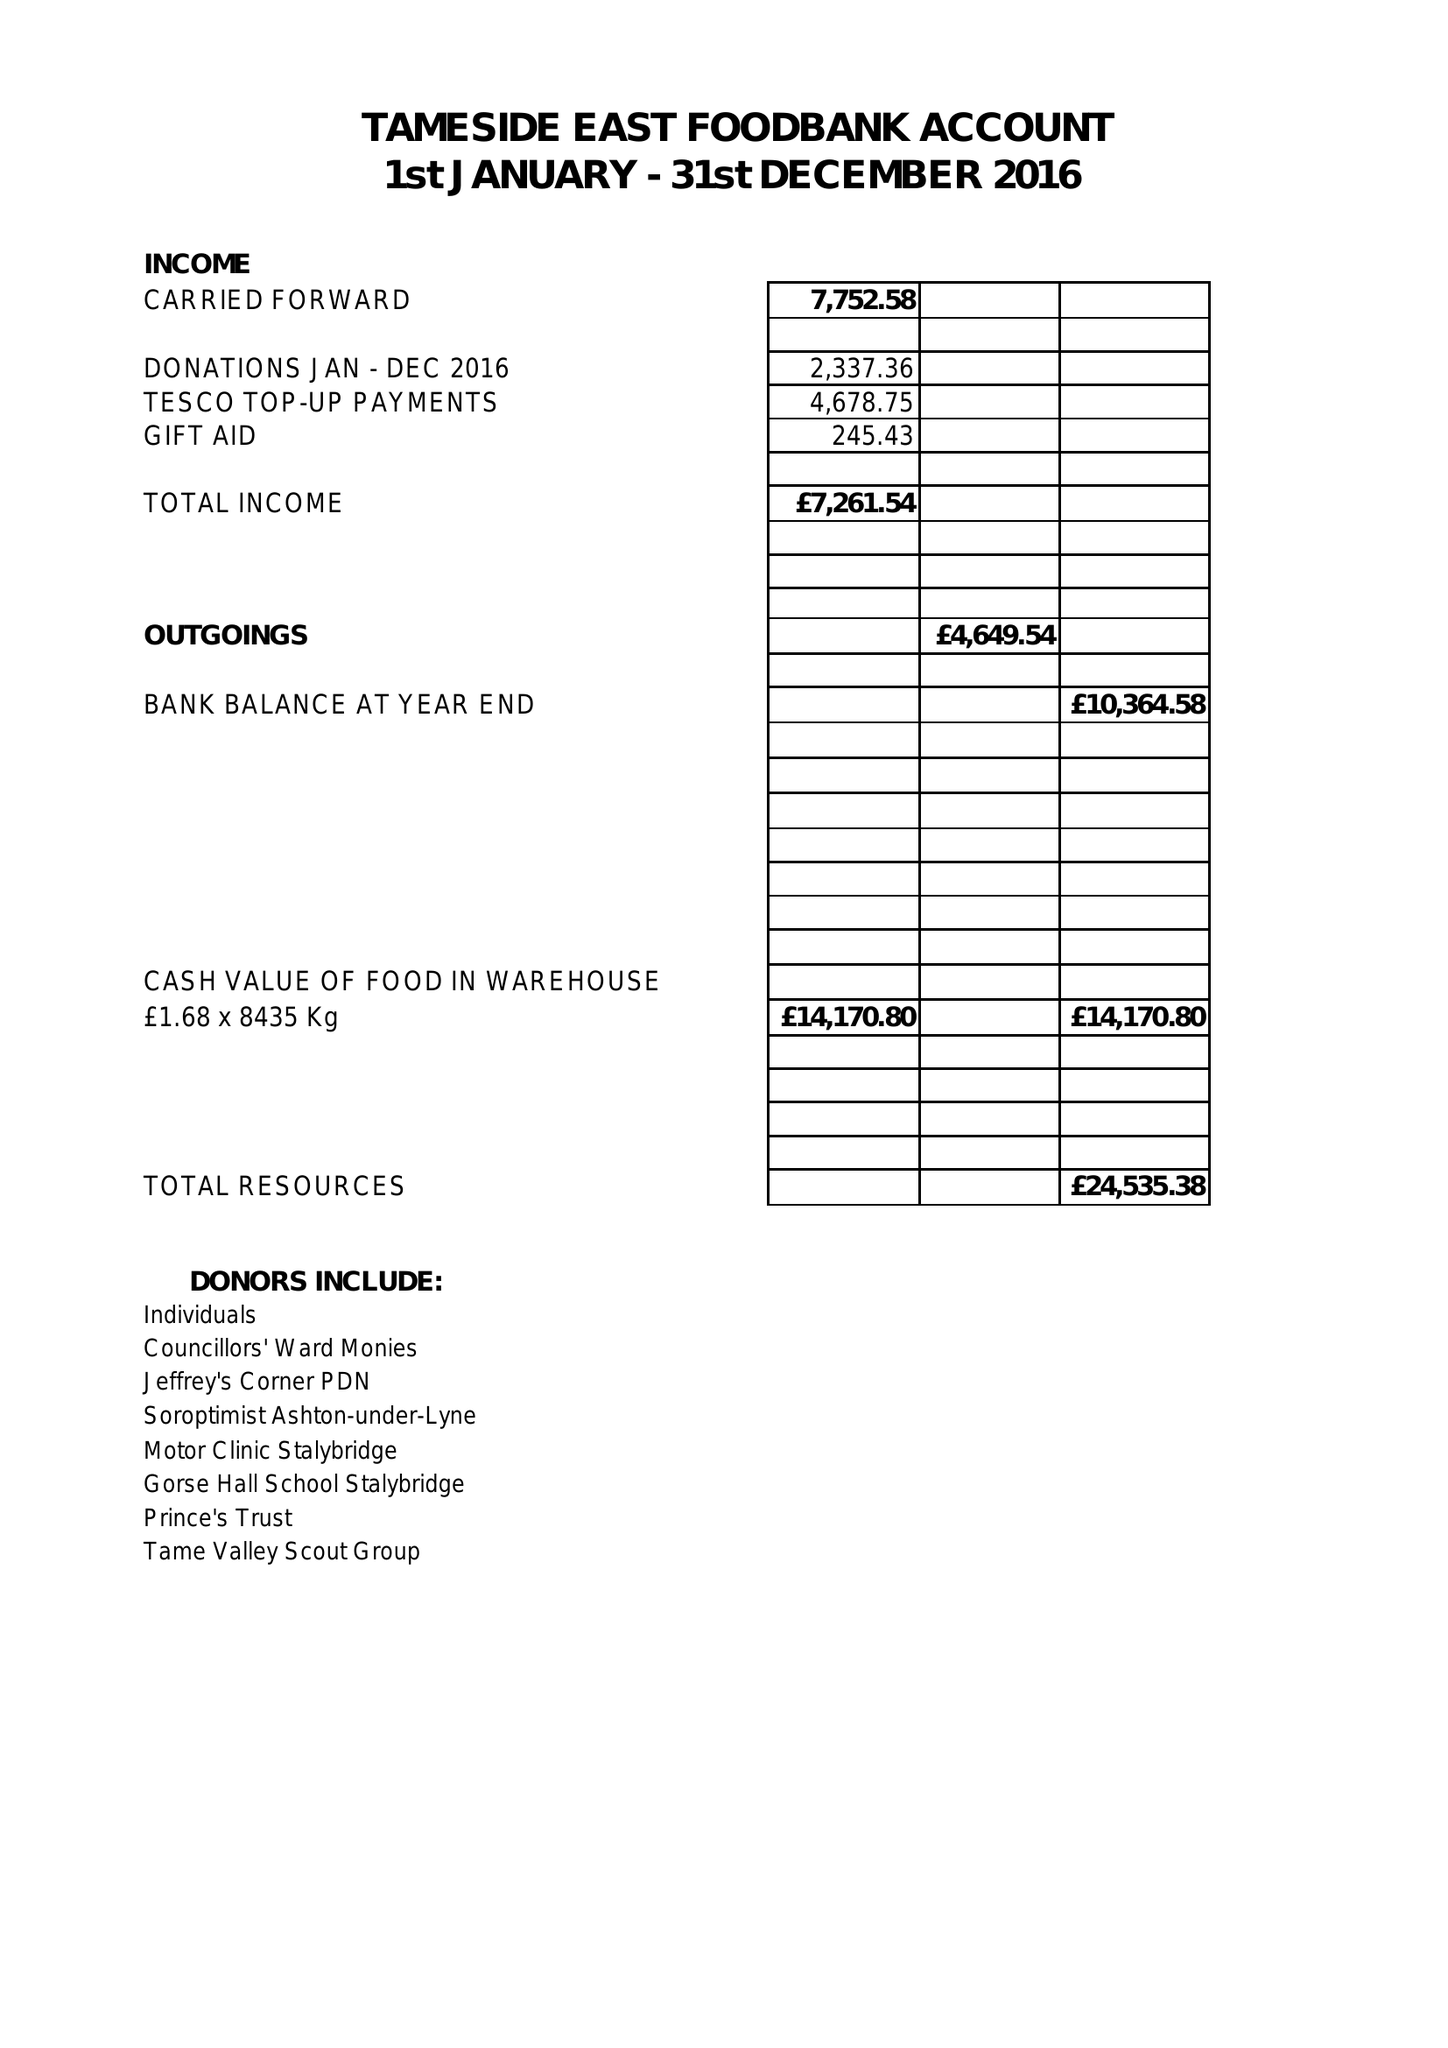What is the value for the income_annually_in_british_pounds?
Answer the question using a single word or phrase. 7261.00 